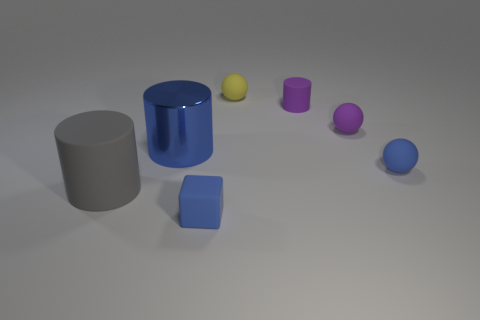Describe the arrangement of the objects. The objects are arranged on a horizontal surface with a semi-random distribution. Starting from the left, there's a grey matte cylinder, followed by a blue glossy cylinder with a slightly small stature. Next, there's a yellow sphere, a small purple matte object, a purple matte cylinder, and finally a blue sphere. 